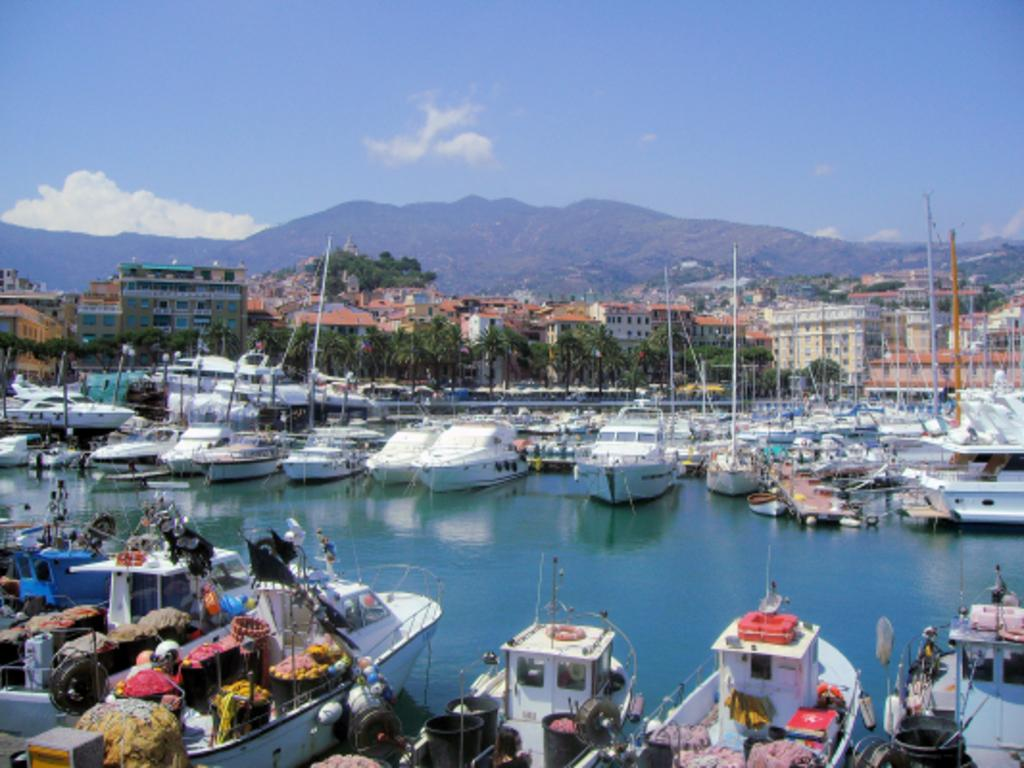What type of vehicles can be seen in the water in the image? There are boats in the water in the image. What structures can be seen in the image? There are buildings visible in the image. What type of vegetation is present in the image? Trees are present in the image. What geographical feature can be seen in the image? There is a hill in the image. How would you describe the sky in the image? The sky is blue and cloudy in the image. Can you tell me how many rats are swimming in the water near the boats? There are no rats present in the image; it features boats in the water. What type of soup is being served in the buildings in the image? There is no soup or indication of food being served in the buildings in the image. 